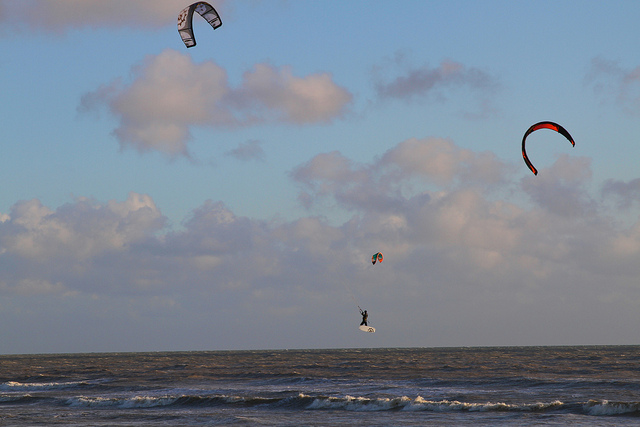Are there any mountains or cityscapes in the background? The panoramic expanse in this image is free from the imprints of mountains or the silhouettes of city skylines, providing an unadulterated view of the natural marine environment. 